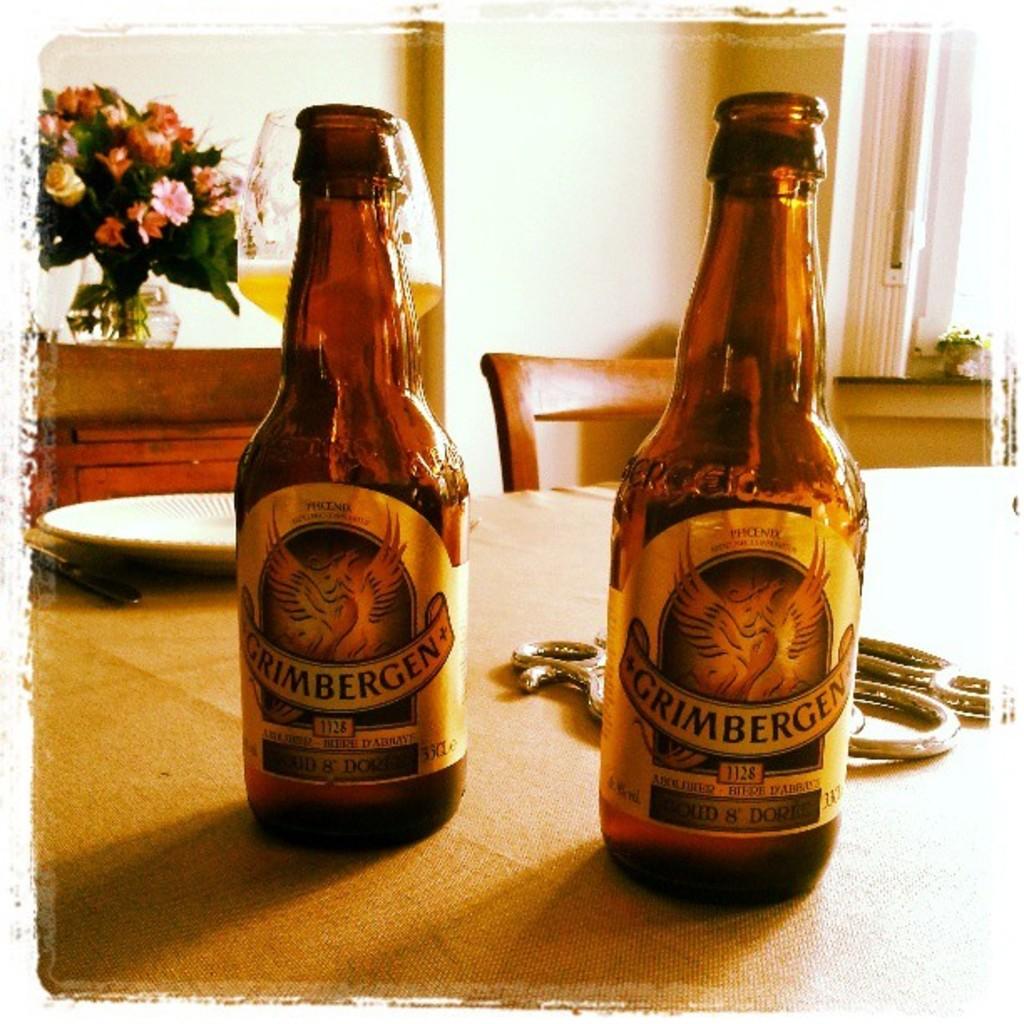What is the brand of the drink?
Your answer should be very brief. Grimbergen. 